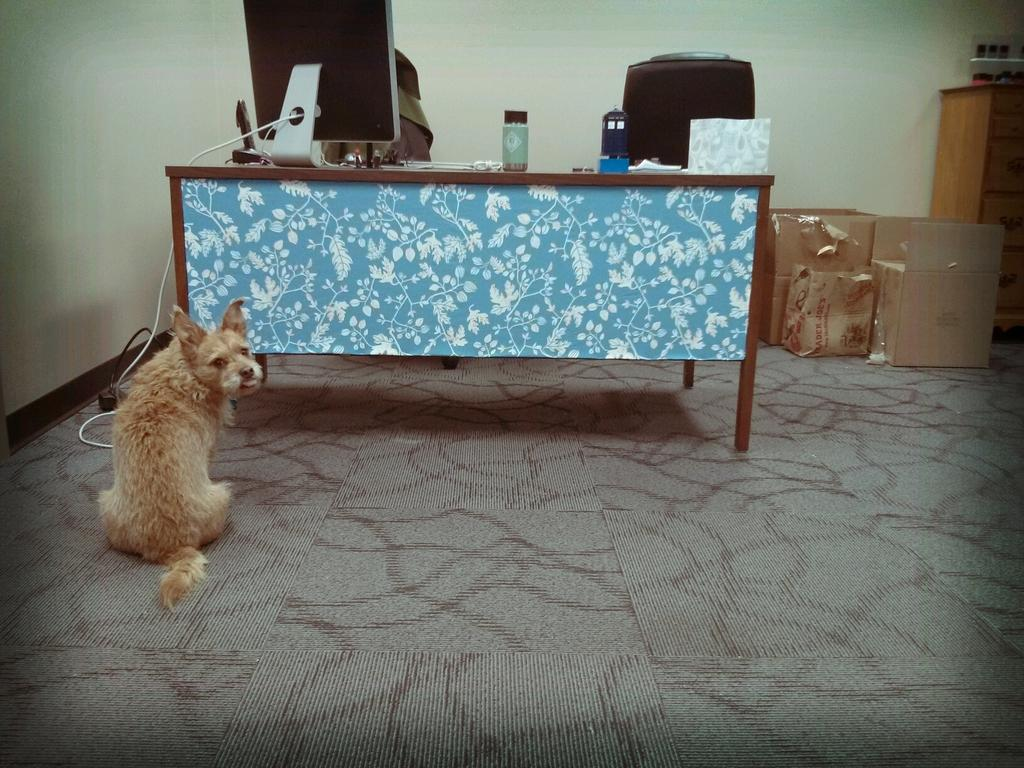What type of animal is on the floor in the image? The facts do not specify the type of animal on the floor. What is located on the table in the image? There is a monitor and a bottle on the table in the image. What piece of furniture is in the image? There is a chair in the image. What can be seen in the background of the image? The background of the image includes a wall. What material is present in the image? Cardboard is present in the image. What type of bells can be heard ringing in the image? There are no bells present in the image, and therefore no sound can be heard. How many legs does the animal on the floor have? The facts do not specify the type of animal on the floor, so we cannot determine the number of legs it has. 